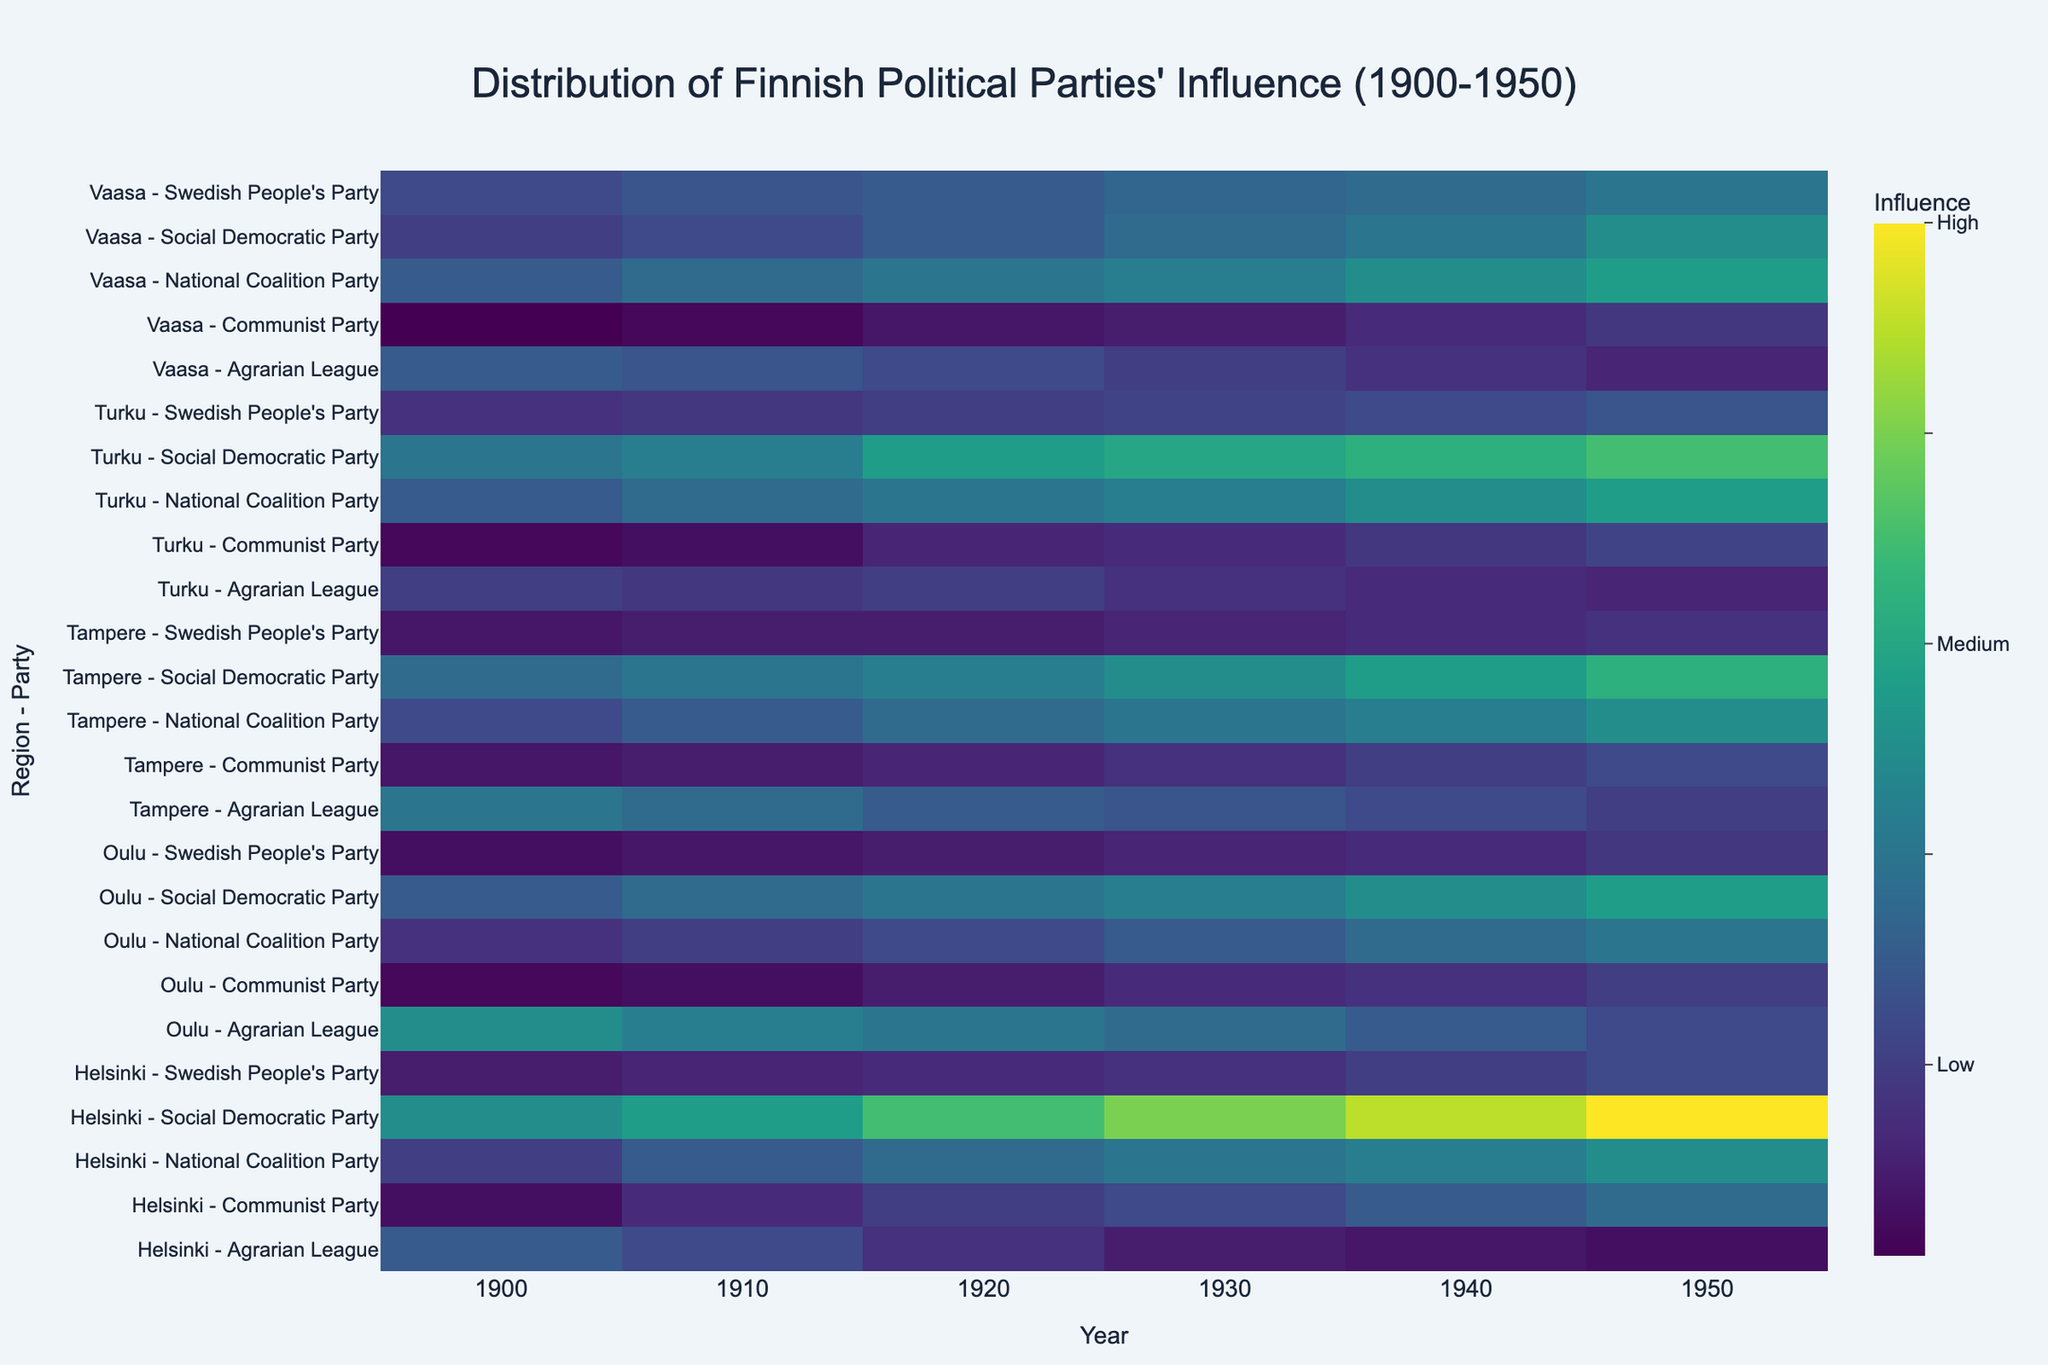What's the most influential political party in Helsinki in 1950? On the heatmap, find the row for Helsinki in 1950 and observe the color intensity for each party. The Social Democratic Party has the highest intensity (darkest color) indicating the highest influence.
Answer: Social Democratic Party Which region had the highest Communist Party influence in 1940? Examine the color intensity for the year 1940 across regions for the Communist Party. Helsinki has the highest intensity (darkest color).
Answer: Helsinki How did the influence of the Agrarian League in Oulu change from 1900 to 1950? Observe the color changes for the Agrarian League in Oulu from 1900 to 1950. The color intensity decreases, indicating a reduction in influence.
Answer: Decreased Which party showed the most significant increase in influence in Turku from 1900 to 1950? Compare the color intensities for each party in Turku from 1900 to 1950. The National Coalition Party shows a significant increase in color intensity, indicating a significant increase in influence.
Answer: National Coalition Party In which year did Tampere see the highest influence from the Swedish People's Party? Check the color intensity for the Swedish People's Party in Tampere across all years. The year 1950 has the highest intensity (darkest color).
Answer: 1950 What's the trend of the National Coalition Party's influence in Vaasa from 1900 to 1950? Follow the color changes for the National Coalition Party in Vaasa from 1900 to 1950. The trend shows an increase in color intensity, indicating rising influence.
Answer: Increasing Which two regions had the same influence levels of the Communist Party in 1910? Compare the color intensities for the Communist Party across regions in 1910. Both Turku and Oulu had similar, low-intensity colors, indicating similar influence levels.
Answer: Turku and Oulu What's the general trend of influence for political parties in Helsinki over the 50-year period? Observe the general color intensities for all parties in Helsinki from 1900 to 1950. All parties show an increase in intensity, indicating a trend of growing political influence.
Answer: Increasing Between Helsinki and Turku, which region had more influence from the Swedish People's Party in 1930? Compare the color intensities for the Swedish People's Party in Helsinki and Turku in 1930. Turku shows a higher intensity (darker color) than Helsinki.
Answer: Turku 